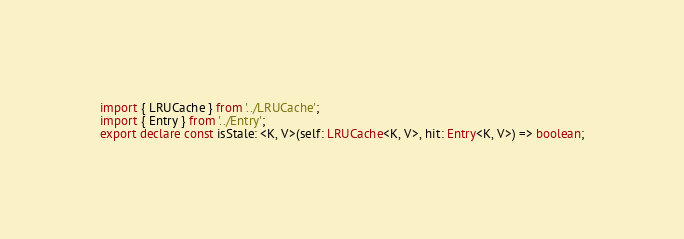Convert code to text. <code><loc_0><loc_0><loc_500><loc_500><_TypeScript_>import { LRUCache } from '../LRUCache';
import { Entry } from '../Entry';
export declare const isStale: <K, V>(self: LRUCache<K, V>, hit: Entry<K, V>) => boolean;
</code> 